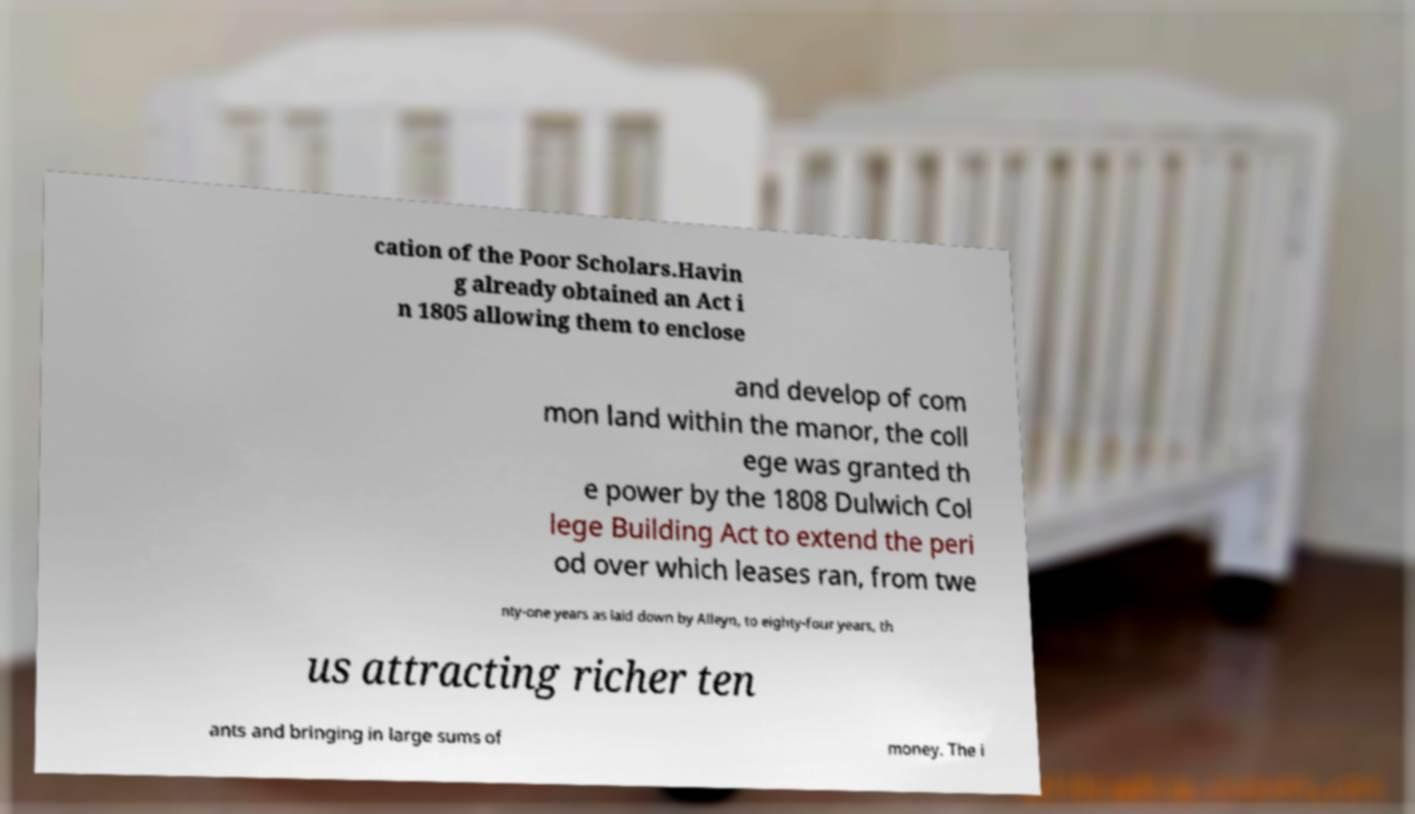Could you assist in decoding the text presented in this image and type it out clearly? cation of the Poor Scholars.Havin g already obtained an Act i n 1805 allowing them to enclose and develop of com mon land within the manor, the coll ege was granted th e power by the 1808 Dulwich Col lege Building Act to extend the peri od over which leases ran, from twe nty-one years as laid down by Alleyn, to eighty-four years, th us attracting richer ten ants and bringing in large sums of money. The i 